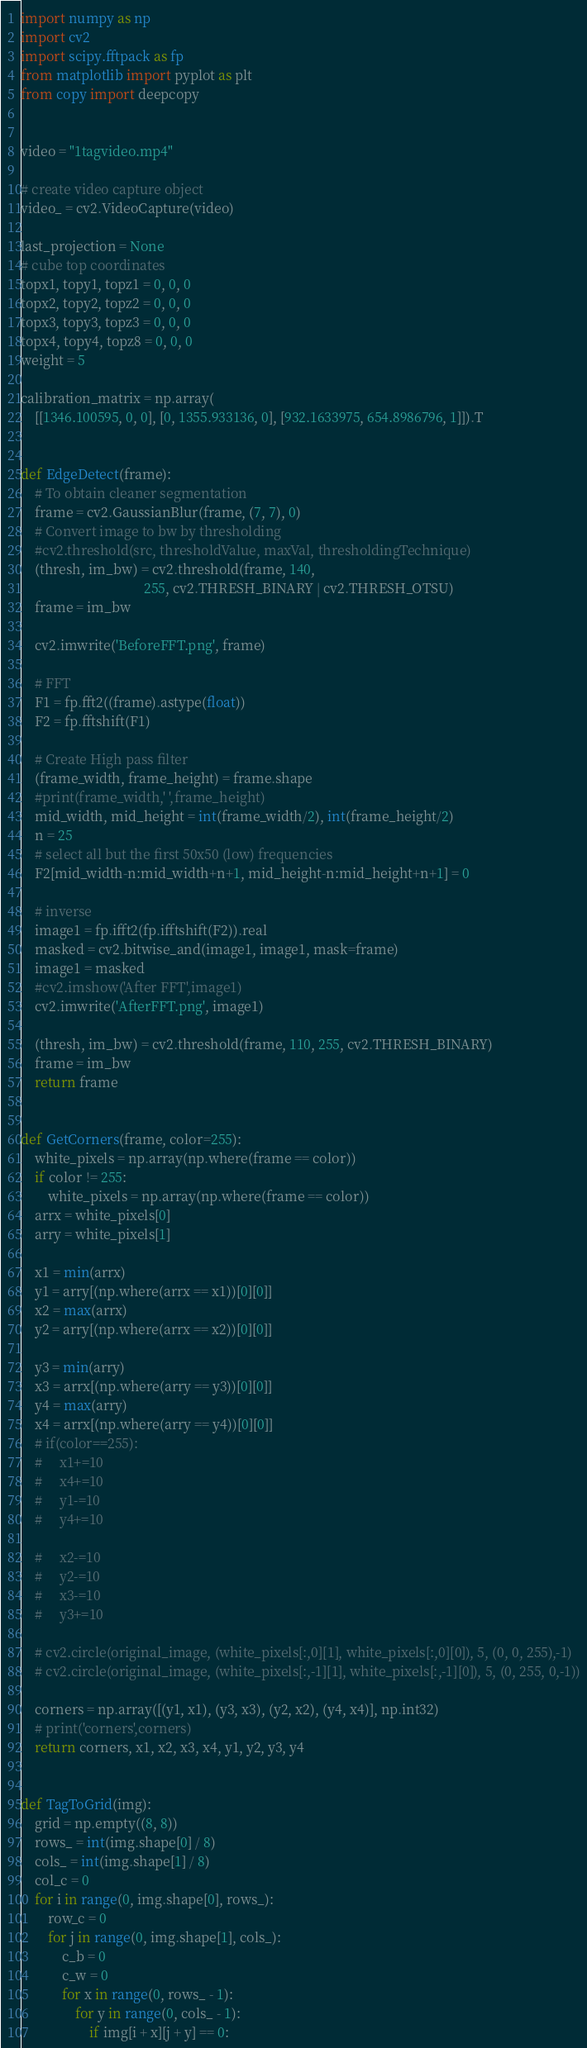Convert code to text. <code><loc_0><loc_0><loc_500><loc_500><_Python_>
import numpy as np
import cv2
import scipy.fftpack as fp
from matplotlib import pyplot as plt
from copy import deepcopy


video = "1tagvideo.mp4"

# create video capture object
video_ = cv2.VideoCapture(video)

last_projection = None
# cube top coordinates
topx1, topy1, topz1 = 0, 0, 0
topx2, topy2, topz2 = 0, 0, 0
topx3, topy3, topz3 = 0, 0, 0
topx4, topy4, topz8 = 0, 0, 0
weight = 5

calibration_matrix = np.array(
    [[1346.100595, 0, 0], [0, 1355.933136, 0], [932.1633975, 654.8986796, 1]]).T


def EdgeDetect(frame):
    # To obtain cleaner segmentation
    frame = cv2.GaussianBlur(frame, (7, 7), 0)
    # Convert image to bw by thresholding
    #cv2.threshold(src, thresholdValue, maxVal, thresholdingTechnique)
    (thresh, im_bw) = cv2.threshold(frame, 140,
                                    255, cv2.THRESH_BINARY | cv2.THRESH_OTSU)
    frame = im_bw

    cv2.imwrite('BeforeFFT.png', frame)

    # FFT
    F1 = fp.fft2((frame).astype(float))
    F2 = fp.fftshift(F1)

    # Create High pass filter
    (frame_width, frame_height) = frame.shape
    #print(frame_width,' ',frame_height)
    mid_width, mid_height = int(frame_width/2), int(frame_height/2)
    n = 25
    # select all but the first 50x50 (low) frequencies
    F2[mid_width-n:mid_width+n+1, mid_height-n:mid_height+n+1] = 0

    # inverse
    image1 = fp.ifft2(fp.ifftshift(F2)).real
    masked = cv2.bitwise_and(image1, image1, mask=frame)
    image1 = masked
    #cv2.imshow('After FFT',image1)
    cv2.imwrite('AfterFFT.png', image1)

    (thresh, im_bw) = cv2.threshold(frame, 110, 255, cv2.THRESH_BINARY)
    frame = im_bw
    return frame


def GetCorners(frame, color=255):
    white_pixels = np.array(np.where(frame == color))
    if color != 255:
        white_pixels = np.array(np.where(frame == color))
    arrx = white_pixels[0]
    arry = white_pixels[1]

    x1 = min(arrx)
    y1 = arry[(np.where(arrx == x1))[0][0]]
    x2 = max(arrx)
    y2 = arry[(np.where(arrx == x2))[0][0]]

    y3 = min(arry)
    x3 = arrx[(np.where(arry == y3))[0][0]]
    y4 = max(arry)
    x4 = arrx[(np.where(arry == y4))[0][0]]
    # if(color==255):
    #     x1+=10
    #     x4+=10
    #     y1-=10
    #     y4+=10

    #     x2-=10
    #     y2-=10
    #     x3-=10
    #     y3+=10

    # cv2.circle(original_image, (white_pixels[:,0][1], white_pixels[:,0][0]), 5, (0, 0, 255),-1)
    # cv2.circle(original_image, (white_pixels[:,-1][1], white_pixels[:,-1][0]), 5, (0, 255, 0,-1))

    corners = np.array([(y1, x1), (y3, x3), (y2, x2), (y4, x4)], np.int32)
    # print('corners',corners)
    return corners, x1, x2, x3, x4, y1, y2, y3, y4


def TagToGrid(img):
    grid = np.empty((8, 8))
    rows_ = int(img.shape[0] / 8)
    cols_ = int(img.shape[1] / 8)
    col_c = 0
    for i in range(0, img.shape[0], rows_):
        row_c = 0
        for j in range(0, img.shape[1], cols_):
            c_b = 0
            c_w = 0
            for x in range(0, rows_ - 1):
                for y in range(0, cols_ - 1):
                    if img[i + x][j + y] == 0:</code> 